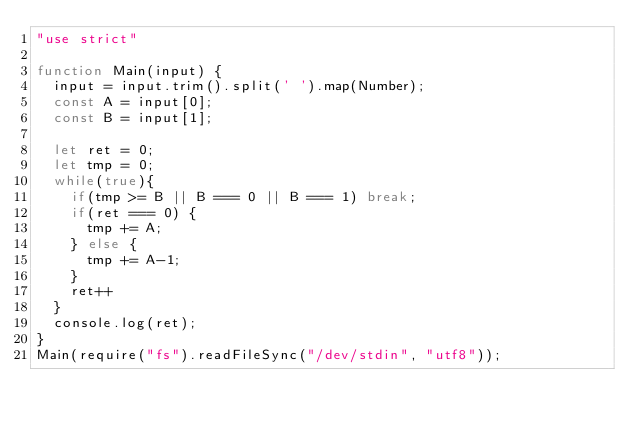Convert code to text. <code><loc_0><loc_0><loc_500><loc_500><_JavaScript_>"use strict"
 
function Main(input) {
  input = input.trim().split(' ').map(Number);
  const A = input[0];
  const B = input[1];
 
  let ret = 0;
  let tmp = 0;
  while(true){
    if(tmp >= B || B === 0 || B === 1) break;
    if(ret === 0) {
      tmp += A;
    } else {
      tmp += A-1;
    }
    ret++
  }
  console.log(ret);
}
Main(require("fs").readFileSync("/dev/stdin", "utf8"));</code> 